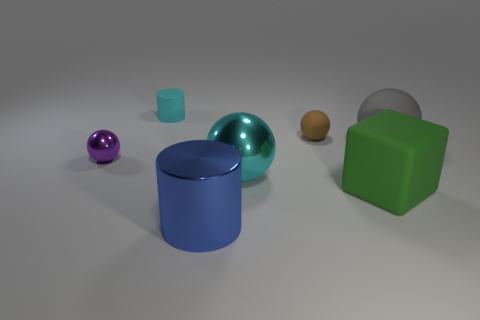Subtract all tiny brown matte balls. How many balls are left? 3 Subtract 1 balls. How many balls are left? 3 Subtract all brown balls. How many balls are left? 3 Subtract all green spheres. Subtract all blue cylinders. How many spheres are left? 4 Add 2 tiny brown matte objects. How many objects exist? 9 Subtract all blocks. How many objects are left? 6 Add 7 blue cylinders. How many blue cylinders are left? 8 Add 6 large red metal cylinders. How many large red metal cylinders exist? 6 Subtract 0 purple cylinders. How many objects are left? 7 Subtract all yellow metal blocks. Subtract all brown rubber things. How many objects are left? 6 